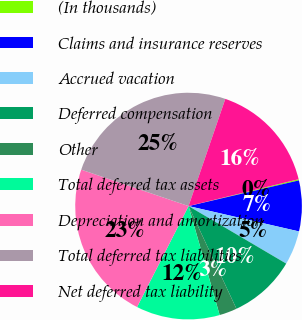Convert chart. <chart><loc_0><loc_0><loc_500><loc_500><pie_chart><fcel>(In thousands)<fcel>Claims and insurance reserves<fcel>Accrued vacation<fcel>Deferred compensation<fcel>Other<fcel>Total deferred tax assets<fcel>Depreciation and amortization<fcel>Total deferred tax liabilities<fcel>Net deferred tax liability<nl><fcel>0.17%<fcel>7.23%<fcel>4.88%<fcel>9.58%<fcel>2.52%<fcel>11.93%<fcel>22.7%<fcel>25.05%<fcel>15.93%<nl></chart> 